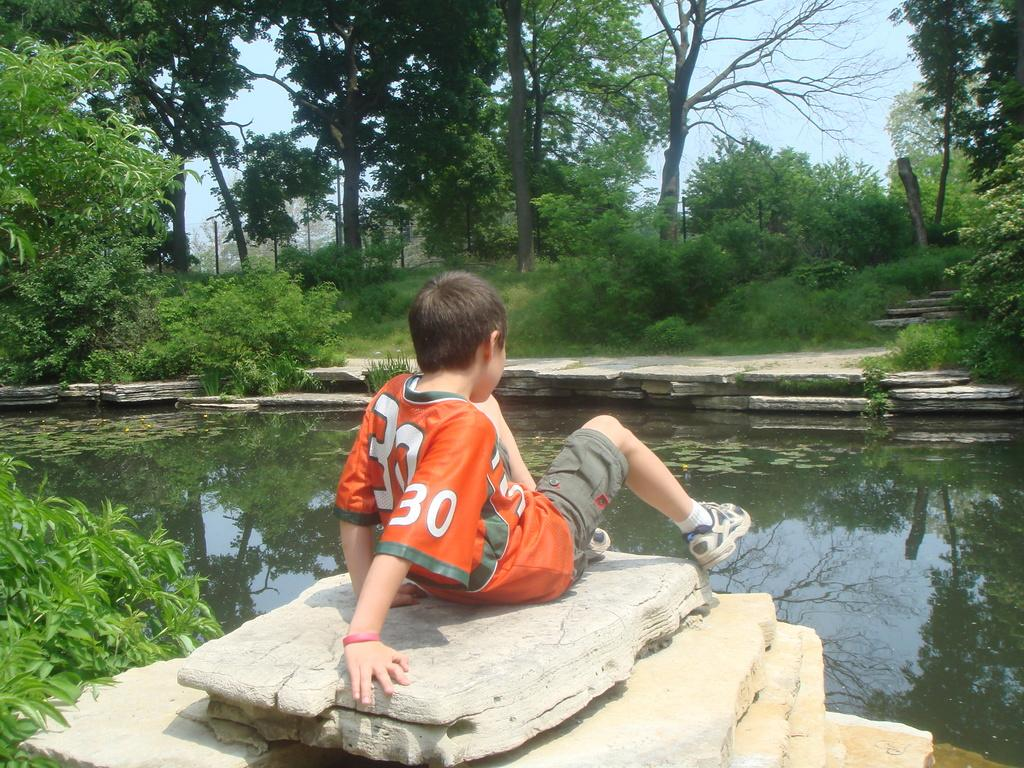Who is the main subject in the image? There is a boy in the middle of the image. What can be seen in the background of the image? There is water and trees visible in the image. What is visible at the top of the image? The sky is visible at the top of the image. What type of dress is the boy wearing in the image? The boy is not wearing a dress in the image; he is wearing regular clothing. How many cakes can be seen on the water in the image? There are no cakes present in the image; it features a boy, water, trees, and the sky. 